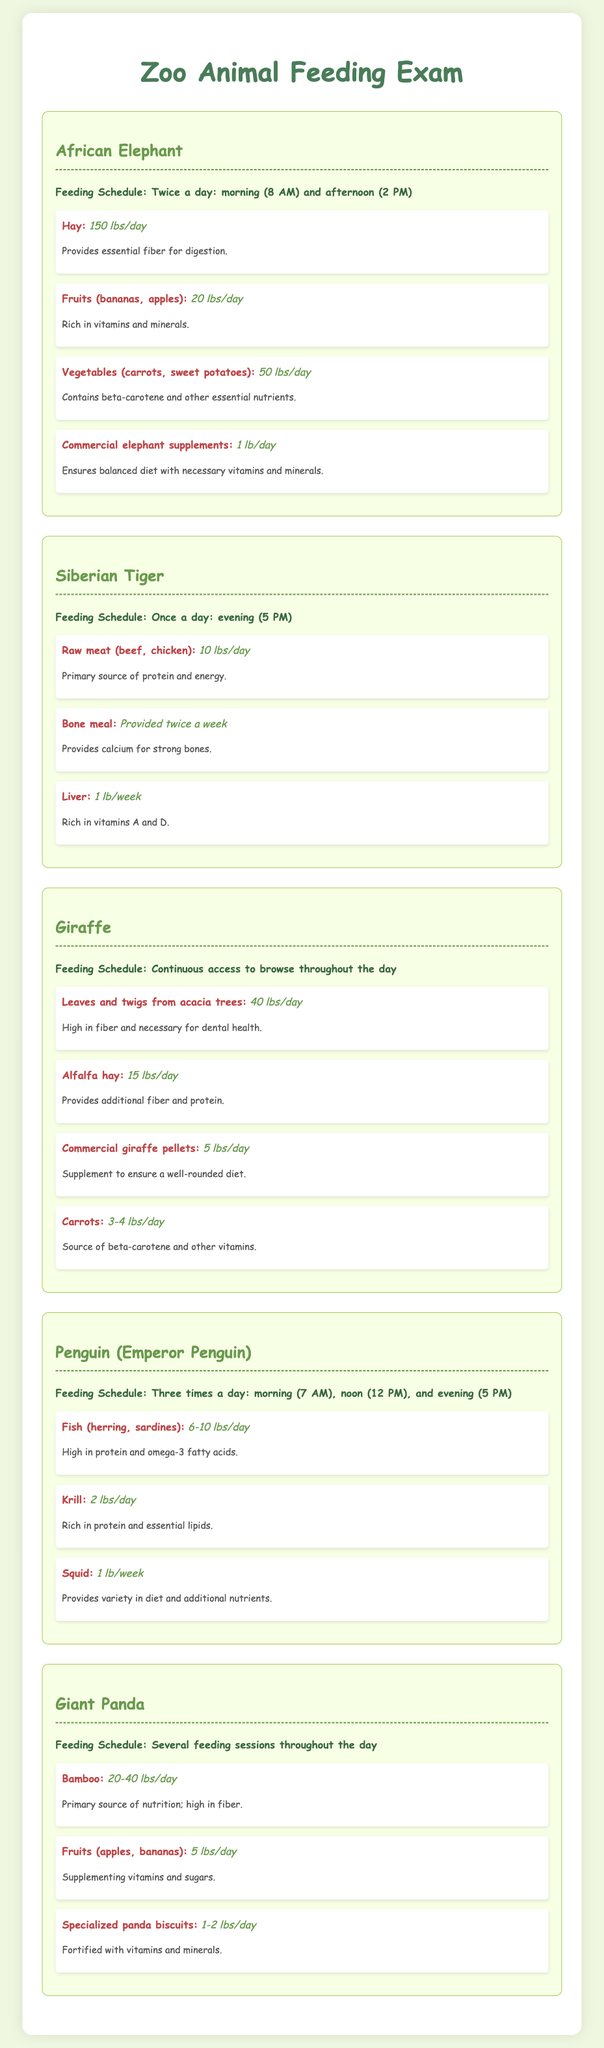What is the feeding schedule for the African Elephant? The African Elephant is fed twice a day: morning (8 AM) and afternoon (2 PM).
Answer: Twice a day: morning (8 AM) and afternoon (2 PM) How much hay does a Siberian Tiger receive daily? The document states that a Siberian Tiger receives 10 lbs of raw meat daily, but it does not mention hay, only meat and other food items.
Answer: 10 lbs/day What type of food does the Giraffe primarily consume? The Giraffe primarily consumes leaves and twigs from acacia trees, along with other food items mentioned.
Answer: Leaves and twigs from acacia trees How often are bones provided to the Siberian Tiger? The document indicates that bone meal is provided to the Siberian Tiger twice a week.
Answer: Twice a week What is the maximum amount of bamboo a Giant Panda consumes per day? The document mentions that a Giant Panda consumes between 20 to 40 lbs of bamboo per day.
Answer: 40 lbs/day What specific food item is included in the feeding schedule for Emperor Penguins only weekly? The Emperor Penguins include squid in their diet, which is provided at a rate of 1 lb per week.
Answer: 1 lb/week What supplements do African Elephants receive for their diet? The document states that African Elephants receive commercial elephant supplements to ensure a balanced diet.
Answer: Commercial elephant supplements What is the total quantity of fruits (bananas, apples) consumed by the African Elephant daily? The daily consumption of fruits (bananas, apples) for the African Elephant is stated as 20 lbs.
Answer: 20 lbs/day How many times a day are Emperor Penguins fed? The feeding schedule for Emperor Penguins indicates that they are fed three times a day.
Answer: Three times a day 